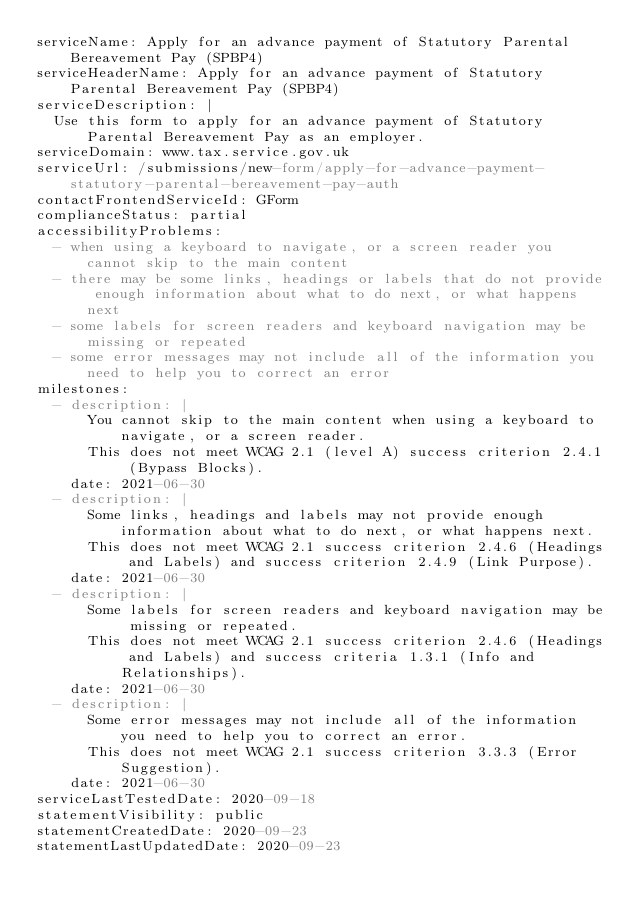Convert code to text. <code><loc_0><loc_0><loc_500><loc_500><_YAML_>serviceName: Apply for an advance payment of Statutory Parental Bereavement Pay (SPBP4)
serviceHeaderName: Apply for an advance payment of Statutory Parental Bereavement Pay (SPBP4)
serviceDescription: |
  Use this form to apply for an advance payment of Statutory Parental Bereavement Pay as an employer.
serviceDomain: www.tax.service.gov.uk
serviceUrl: /submissions/new-form/apply-for-advance-payment-statutory-parental-bereavement-pay-auth
contactFrontendServiceId: GForm
complianceStatus: partial
accessibilityProblems:
  - when using a keyboard to navigate, or a screen reader you cannot skip to the main content
  - there may be some links, headings or labels that do not provide enough information about what to do next, or what happens next
  - some labels for screen readers and keyboard navigation may be missing or repeated
  - some error messages may not include all of the information you need to help you to correct an error
milestones:
  - description: |
      You cannot skip to the main content when using a keyboard to navigate, or a screen reader.
      This does not meet WCAG 2.1 (level A) success criterion 2.4.1 (Bypass Blocks).
    date: 2021-06-30
  - description: |
      Some links, headings and labels may not provide enough information about what to do next, or what happens next.
      This does not meet WCAG 2.1 success criterion 2.4.6 (Headings and Labels) and success criterion 2.4.9 (Link Purpose).
    date: 2021-06-30
  - description: |
      Some labels for screen readers and keyboard navigation may be missing or repeated.
      This does not meet WCAG 2.1 success criterion 2.4.6 (Headings and Labels) and success criteria 1.3.1 (Info and Relationships).
    date: 2021-06-30
  - description: |
      Some error messages may not include all of the information you need to help you to correct an error.
      This does not meet WCAG 2.1 success criterion 3.3.3 (Error Suggestion).
    date: 2021-06-30
serviceLastTestedDate: 2020-09-18
statementVisibility: public
statementCreatedDate: 2020-09-23
statementLastUpdatedDate: 2020-09-23</code> 